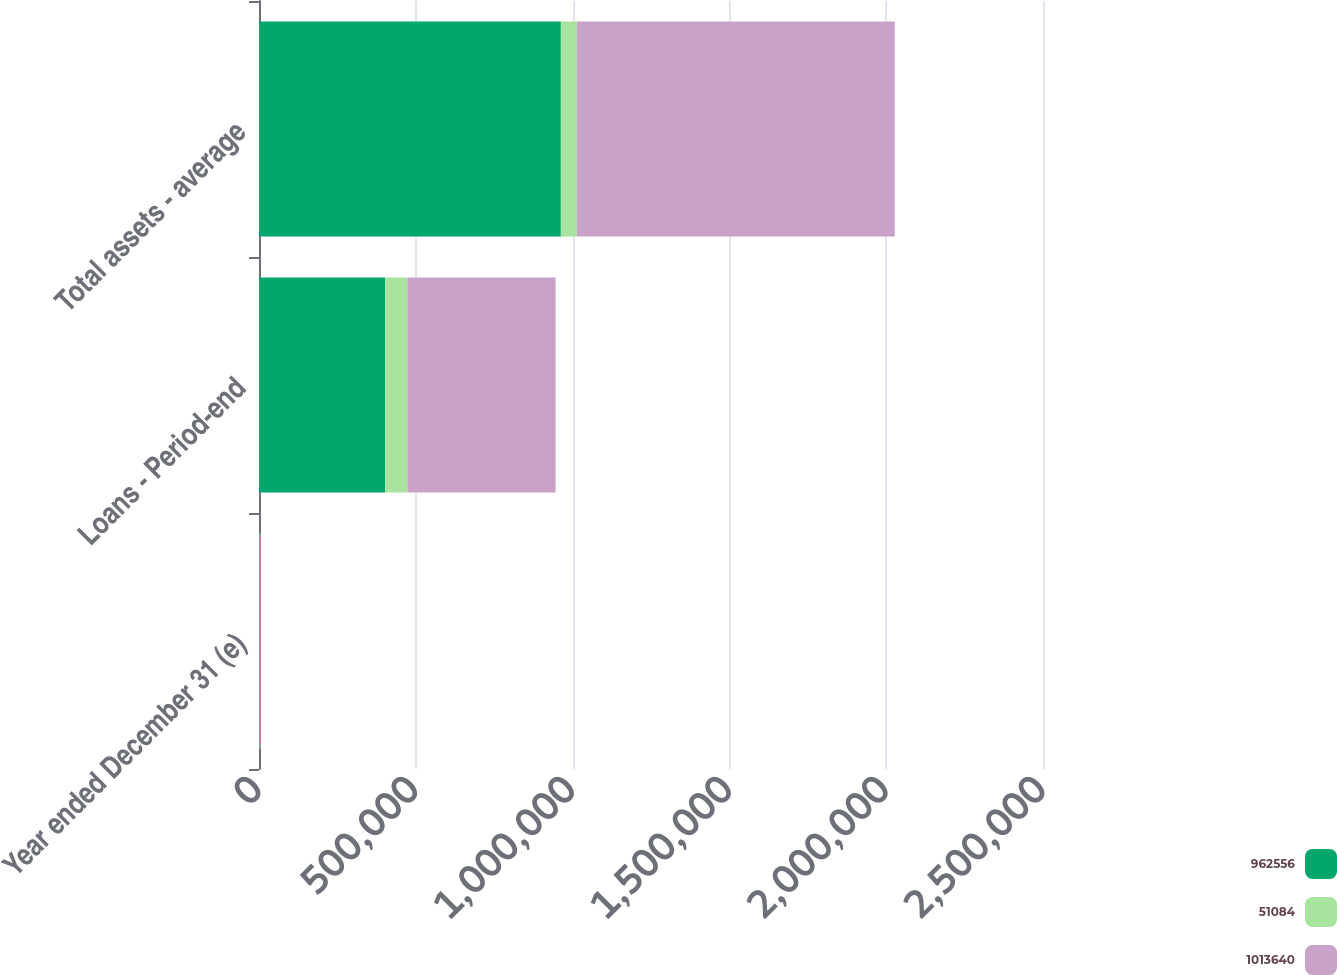Convert chart to OTSL. <chart><loc_0><loc_0><loc_500><loc_500><stacked_bar_chart><ecel><fcel>Year ended December 31 (e)<fcel>Loans - Period-end<fcel>Total assets - average<nl><fcel>962556<fcel>2004<fcel>402114<fcel>962556<nl><fcel>51084<fcel>2004<fcel>70795<fcel>51084<nl><fcel>1.01364e+06<fcel>2004<fcel>472909<fcel>1.01364e+06<nl></chart> 